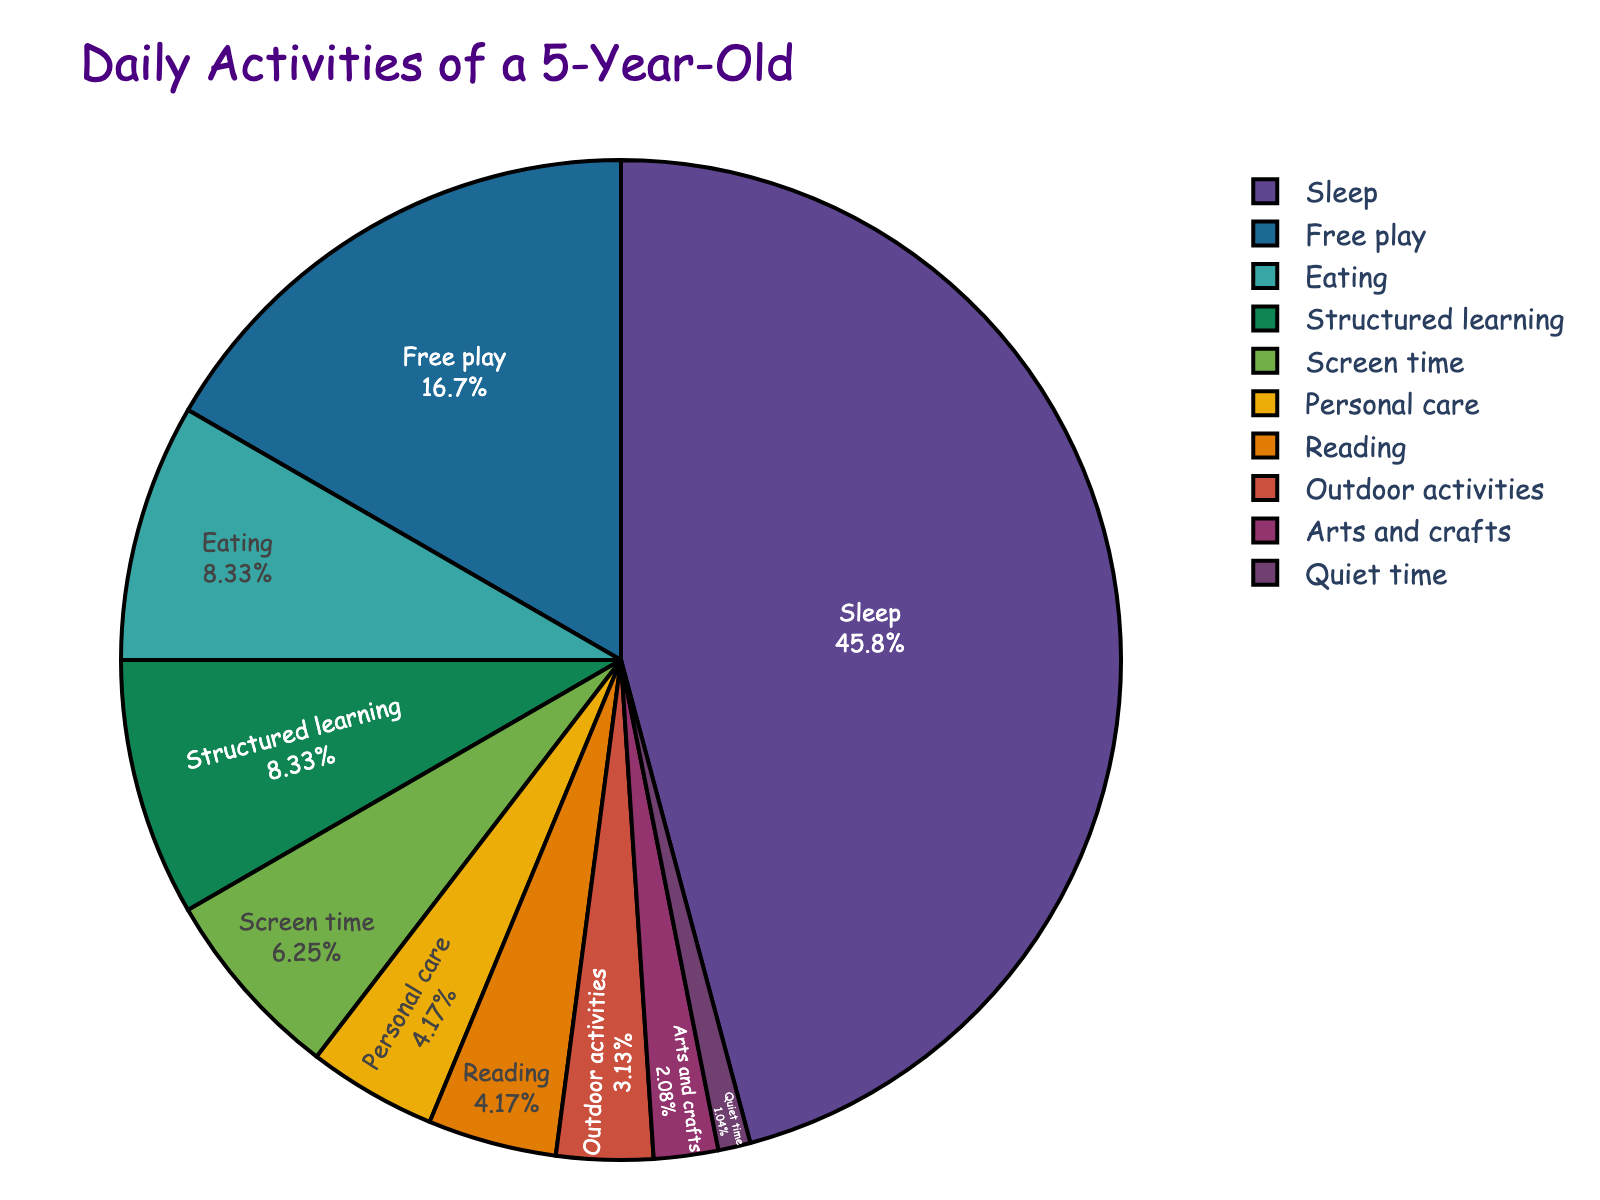How many hours are spent on eating and personal care combined? Adding the hours spent on eating (2) and personal care (1), the total is 2 + 1 = 3 hours.
Answer: 3 Which activity takes up the largest portion of the day? Looking at the pie chart, the largest portion is for sleep, which takes up 11 hours.
Answer: Sleep What is the smallest activity in terms of hours, and how much time is spent on it? The smallest activity slice in the pie chart is for quiet time, which occupies 0.25 hours.
Answer: Quiet time, 0.25 How much more time is allocated to outdoor activities than arts and crafts? Outdoor activities take 0.75 hours, while arts and crafts take 0.5 hours, so the difference is 0.75 - 0.5 = 0.25 hours.
Answer: 0.25 What percentage of the day is dedicated to screen time? The total hours in a day dedicated to activities is 24. Screen time takes 1.5 hours, so the percentage is (1.5 / 24) * 100 = 6.25%.
Answer: 6.25% Which activities take up more than 3 hours combined? Adding hours for activities more than 3: Sleep (11) and Free play (4), those are the activities summing more than 3 hours each.
Answer: Sleep, Free play How does the time spent on structured learning compare to the time spent on reading? Structured learning takes 2 hours, and reading takes 1 hour. Structured learning takes twice as much time as reading.
Answer: Twice What is the ratio of hours spent between screen time and arts and crafts? Screen time is 1.5 hours, and arts and crafts is 0.5 hours. The ratio is 1.5 : 0.5, simplifying to 3:1.
Answer: 3:1 If 3 hours from sleep were reallocated to outdoor activities, what would be the new amount of time spent on each? Sleep originally has 11 hours, minus 3 hours results in 8 hours for sleep. Outdoor activities originally have 0.75 hours, adding 3 hours results in 0.75 + 3 = 3.75 hours for outdoor activities.
Answer: Sleep: 8, Outdoor activities: 3.75 